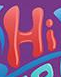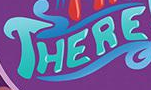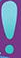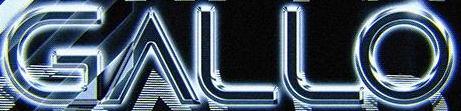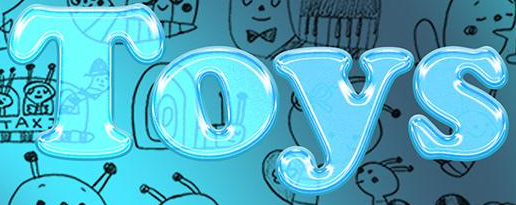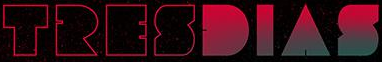Identify the words shown in these images in order, separated by a semicolon. Hi; THERE; !; GALLO; Toys; TRESDIAS 